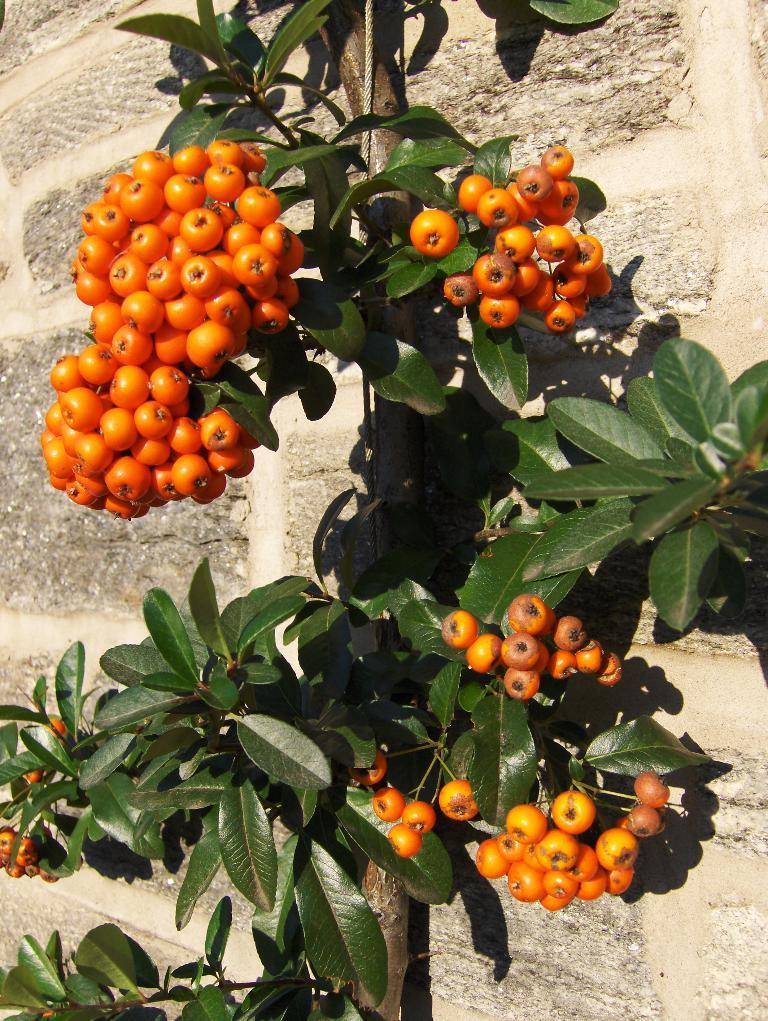What is the main subject in the center of the image? There is a tree in the center of the image. What can be observed on the tree? The tree has fruits. What can be seen in the background of the image? There is a wall in the background of the image. What type of carriage is parked next to the tree in the image? There is no carriage present in the image; it only features a tree with fruits and a wall in the background. 